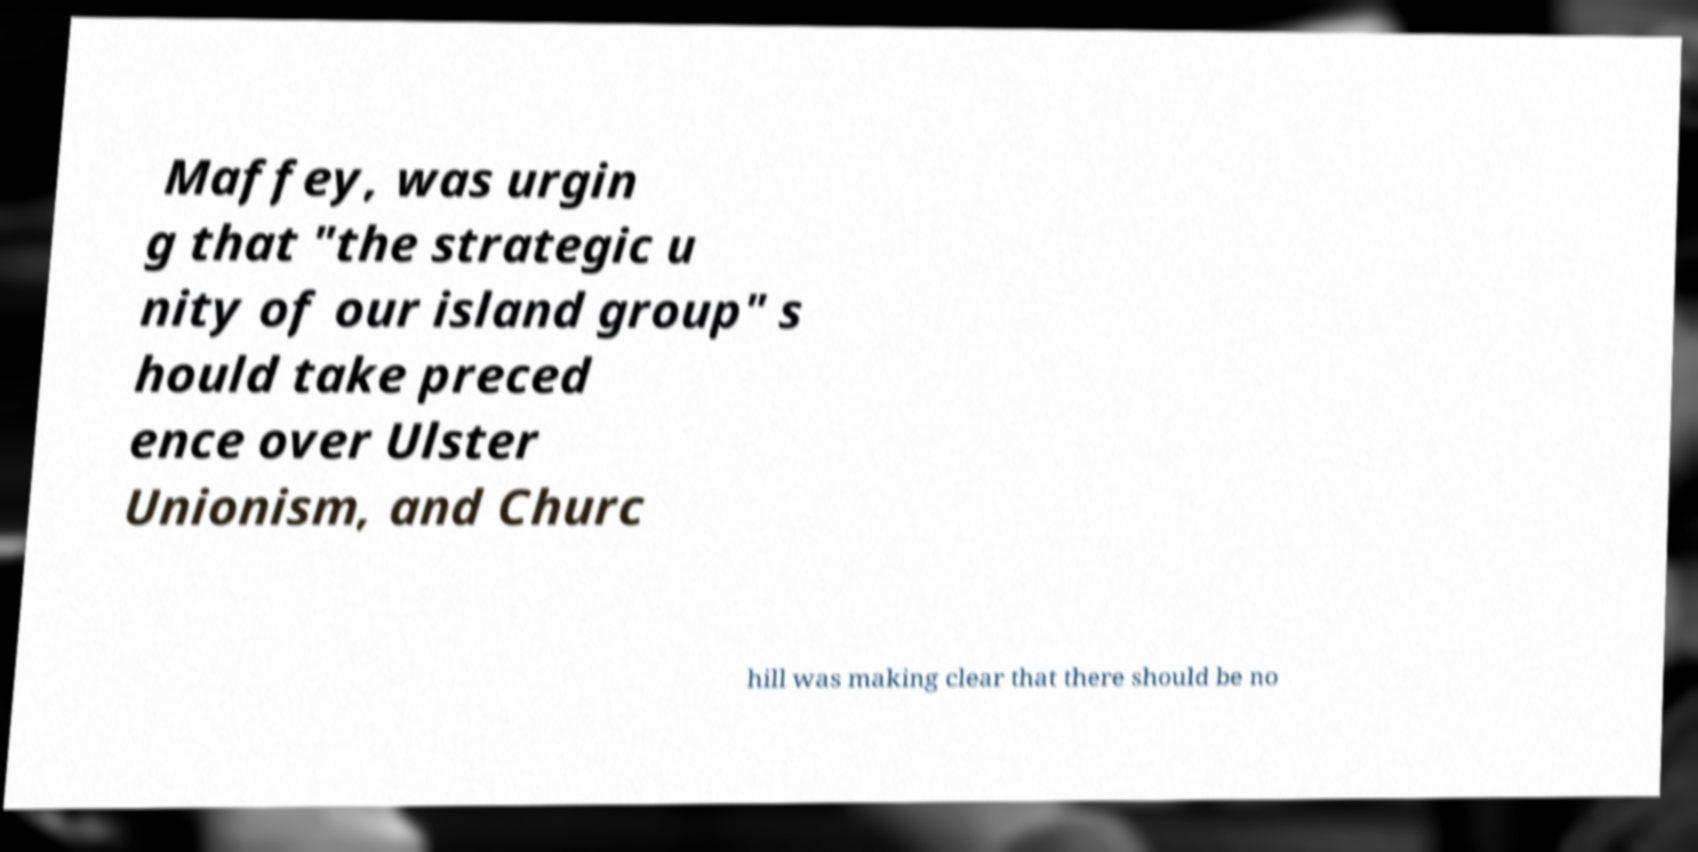For documentation purposes, I need the text within this image transcribed. Could you provide that? Maffey, was urgin g that "the strategic u nity of our island group" s hould take preced ence over Ulster Unionism, and Churc hill was making clear that there should be no 